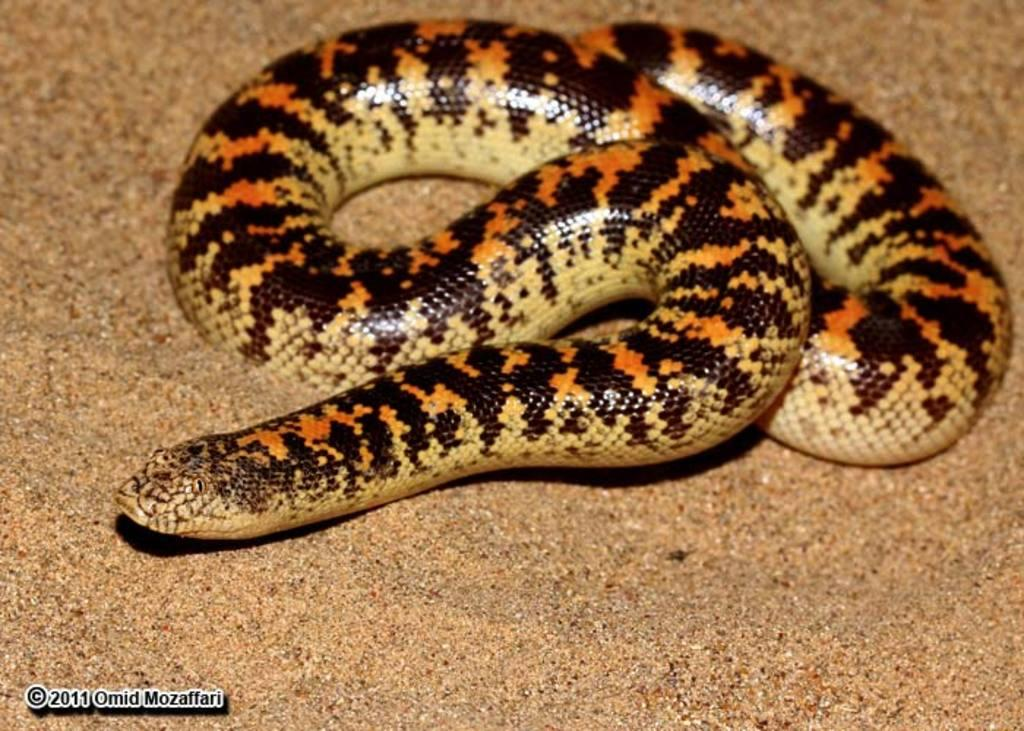What animal is present in the image? There is a snake in the image. Can you describe the colors of the snake? The snake has black, orange, and yellow colors. What can be observed about the background of the image? The background of the image is blurred. What type of dinner is being served in the image? There is no dinner present in the image; it features a snake with black, orange, and yellow colors against a blurred background. What gardening tool can be seen in the image? There is no gardening tool, such as a spade, present in the image. 